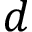<formula> <loc_0><loc_0><loc_500><loc_500>d</formula> 